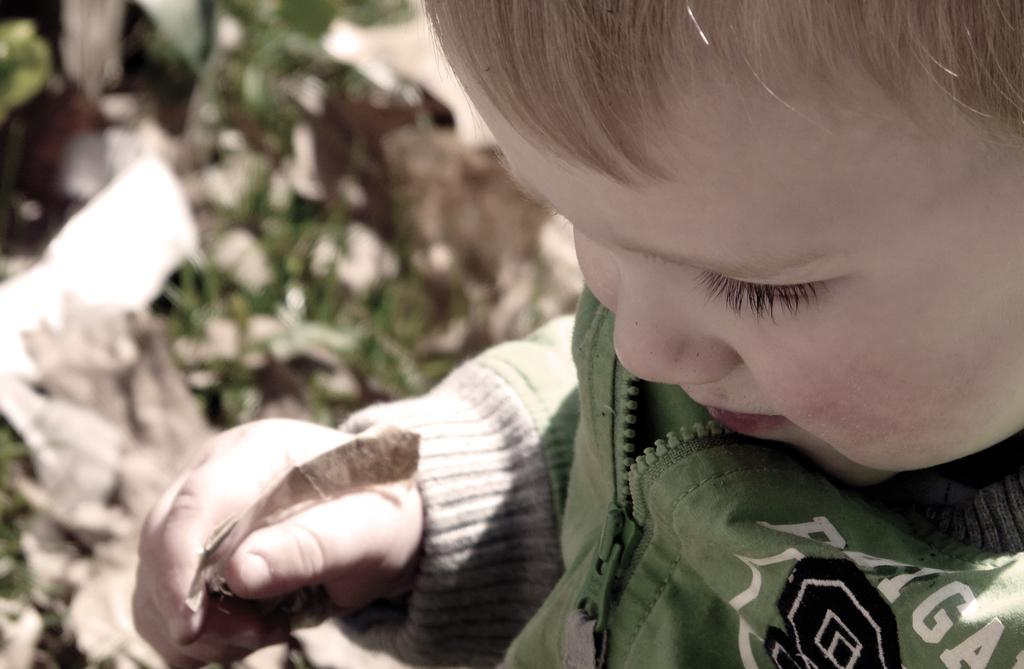What is the main subject in the foreground of the image? There is a boy in the foreground of the image. What is the boy holding in the image? The boy is holding something in the image. What can be seen in the background of the image? There are plants in the background of the image. What type of glue is the boy using to stick the meat in the image? There is no glue or meat present in the image; the boy is simply holding something. 